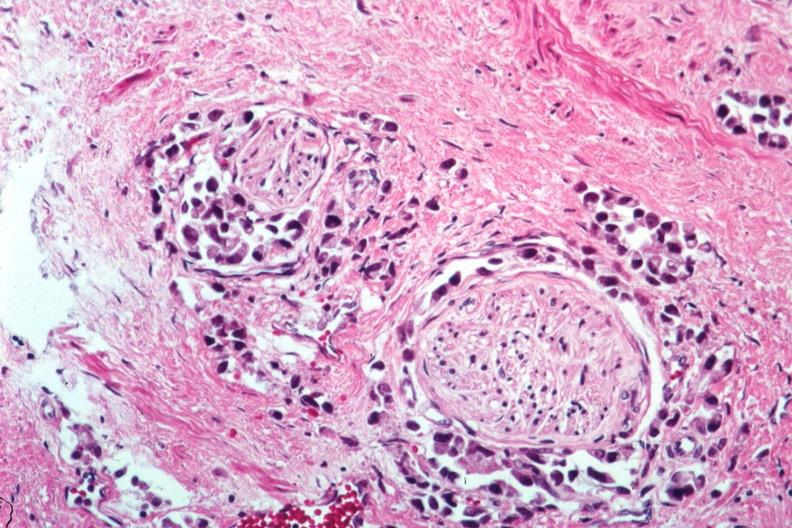s prostate present?
Answer the question using a single word or phrase. Yes 